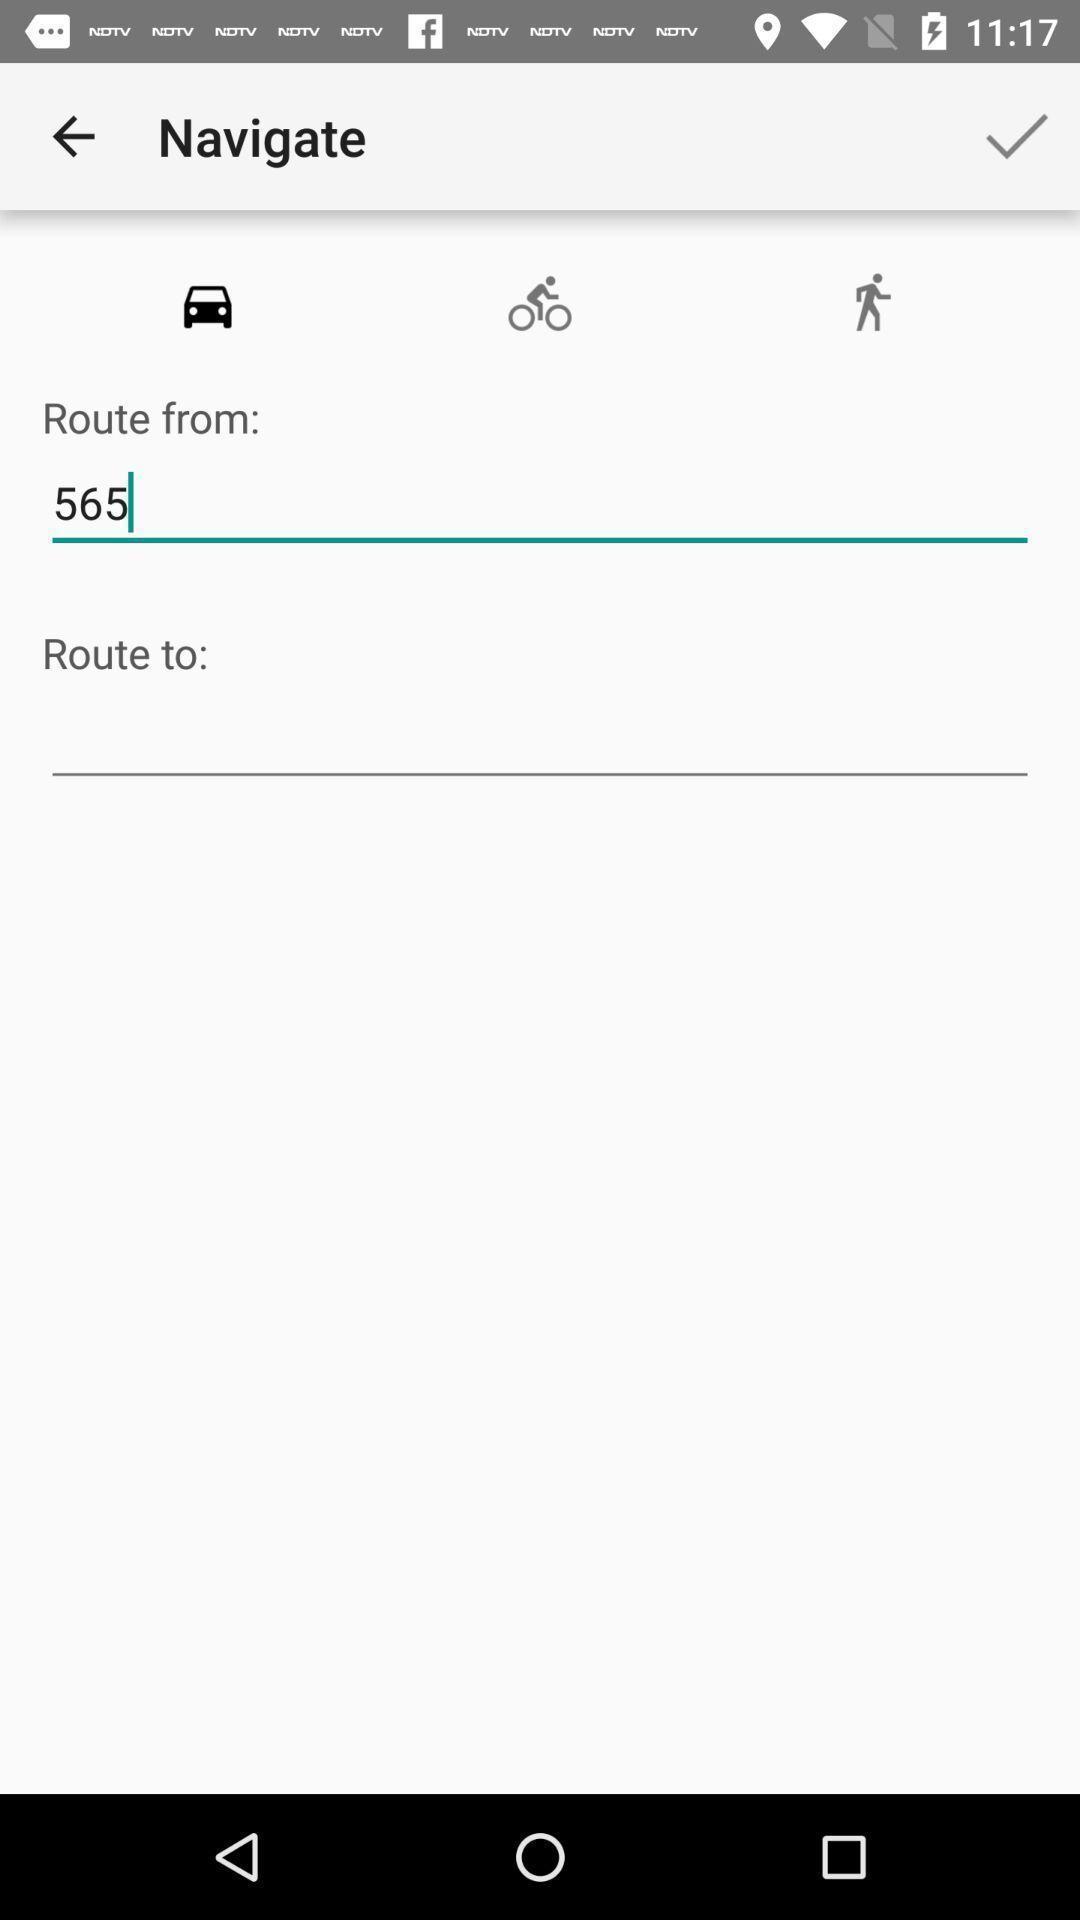Describe the content in this image. Screen displaying multiple options in a navigation application. 